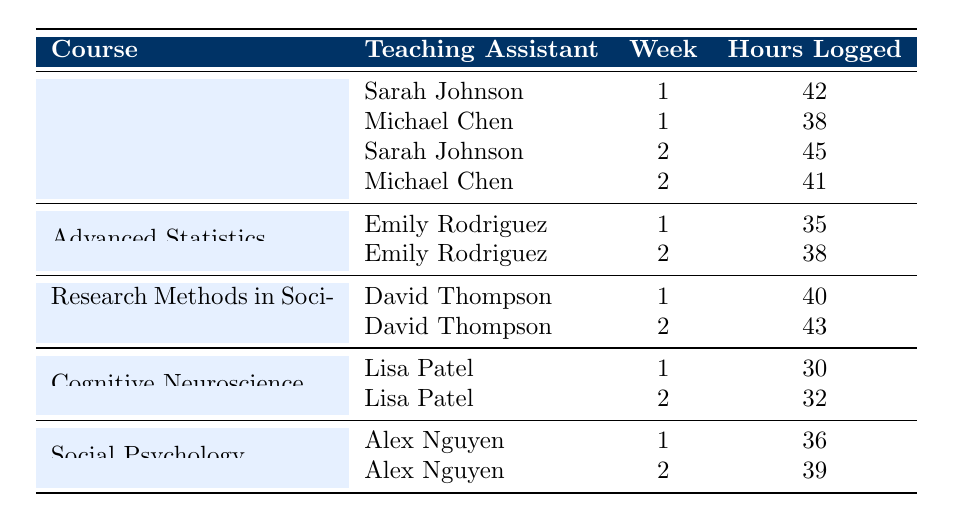What is the total number of teaching assistant hours logged for the course "Introduction to Psychology"? To find the total hours logged, we add the hours for each teaching assistant in that course: 42 (Sarah Johnson, week 1) + 38 (Michael Chen, week 1) + 45 (Sarah Johnson, week 2) + 41 (Michael Chen, week 2) = 166 hours.
Answer: 166 Who logged more hours for the course "Advanced Statistics", Emily Rodriguez in week 1 or week 2? Emily logged 35 hours in week 1 and 38 hours in week 2. Comparing these values, she logged more hours in week 2.
Answer: Week 2 How many hours did Alex Nguyen log across both weeks for "Social Psychology"? We add Alex's hours in both weeks: 36 (week 1) + 39 (week 2) = 75 hours total.
Answer: 75 Did Sarah Johnson log more hours than Michael Chen in week 2 for "Introduction to Psychology"? Sarah logged 45 hours and Michael logged 41 hours in week 2. Comparing these values, Sarah logged more hours than Michael.
Answer: Yes What is the average number of hours logged by the teaching assistants for "Cognitive Neuroscience"? There were 2 data points for the course: 30 hours (week 1) and 32 hours (week 2). To find the average, we sum these values (30 + 32 = 62) and divide by the number of weeks (2). So, 62/2 = 31 hours.
Answer: 31 Which teaching assistant logged the most hours in week 1, and how many hours did they log? We need to compare the hours logged in week 1: Sarah Johnson (42), Michael Chen (38), Emily Rodriguez (35), David Thompson (40), Lisa Patel (30), and Alex Nguyen (36). The maximum value is 42 hours logged by Sarah Johnson.
Answer: Sarah Johnson, 42 How many total hours were logged across all weeks for "Research Methods in Sociology"? We sum the hours for David Thompson: 40 hours (week 1) + 43 hours (week 2) = 83 hours total.
Answer: 83 Which teaching assistant worked on the most diverse set of courses based on the table? From the data, Sarah Johnson worked on "Introduction to Psychology," and no other assistant worked on more than one course. Thus, the answer is Sarah Johnson.
Answer: Sarah Johnson 